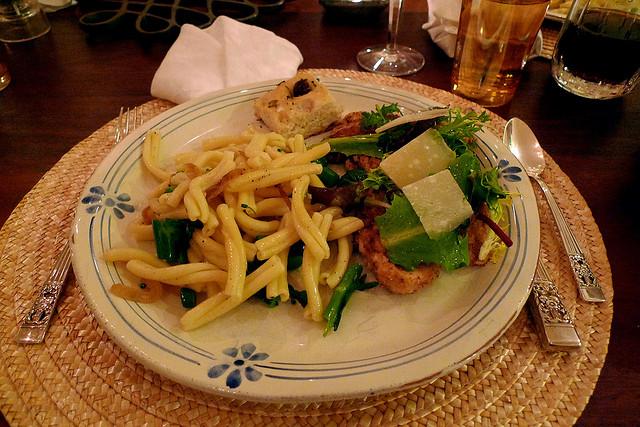What kind of food is this?
Answer briefly. Pasta. Has the meal started?
Write a very short answer. Yes. What utensils are there?
Keep it brief. Fork, knife, spoon. 